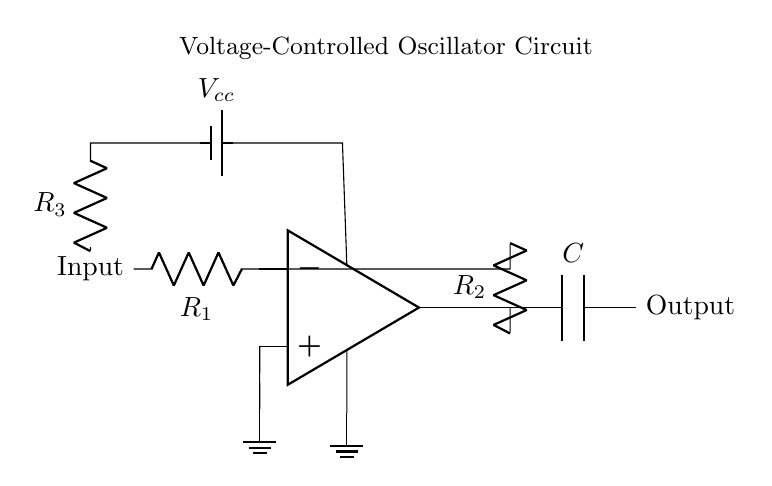What component is used for feedback in this circuit? The feedback component is mainly represented by the resistor R2, which connects the output back to the inverting input of the op-amp. This configuration is critical for generating oscillations in the circuit.
Answer: R2 What is the role of the capacitor in this oscillator circuit? The capacitor C in this circuit is responsible for determining the frequency of oscillation, along with the resistors. It stores energy and releases it, creating periodic charging and discharging, essential for synthesizing tones.
Answer: Frequency control How many resistors are present in this circuit? There are three resistors, identified as R1, R2, and R3, that are crucial for setting gain, feedback, and input biasing conditions in the oscillator circuit.
Answer: Three What is the purpose of the voltage source in this circuit? The voltage source, labeled as Vcc, is essential to power the op-amp and the rest of the circuit, providing the necessary operating voltage for proper functionality.
Answer: Power supply What type of circuit is this? This circuit is a voltage-controlled oscillator (VCO), which generates oscillating signals whose frequency can be controlled by an input voltage, used frequently in synthesizers for sound generation.
Answer: Voltage-controlled oscillator What happens if resistor R3 is increased? Increasing resistor R3 will generally result in a decrease in input bias current, which can indirectly affect the stability of oscillation and the overall waveform produced at the output. Calculating precise effects requires understanding the entire circuit dynamics, but it typically alters the gain and may lower the oscillator frequency.
Answer: Decreases input current What is the output notation in the diagram? The output is denoted at the terminal labeled "Output". The connection indicates where the synthesized signal can be accessed for further amplification or processing.
Answer: Output terminal 